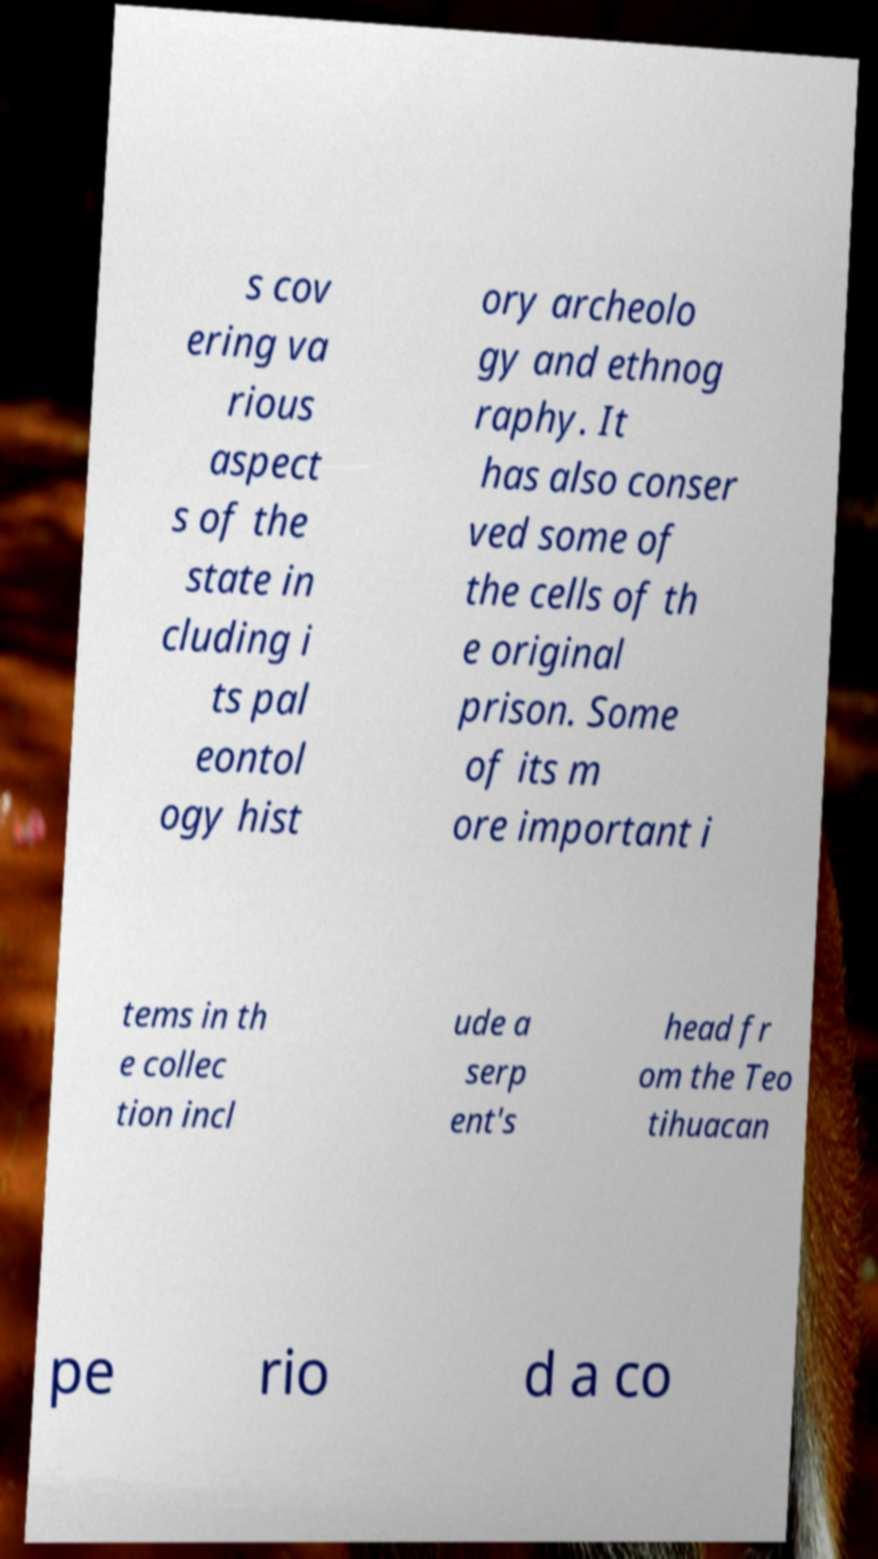Can you accurately transcribe the text from the provided image for me? s cov ering va rious aspect s of the state in cluding i ts pal eontol ogy hist ory archeolo gy and ethnog raphy. It has also conser ved some of the cells of th e original prison. Some of its m ore important i tems in th e collec tion incl ude a serp ent's head fr om the Teo tihuacan pe rio d a co 